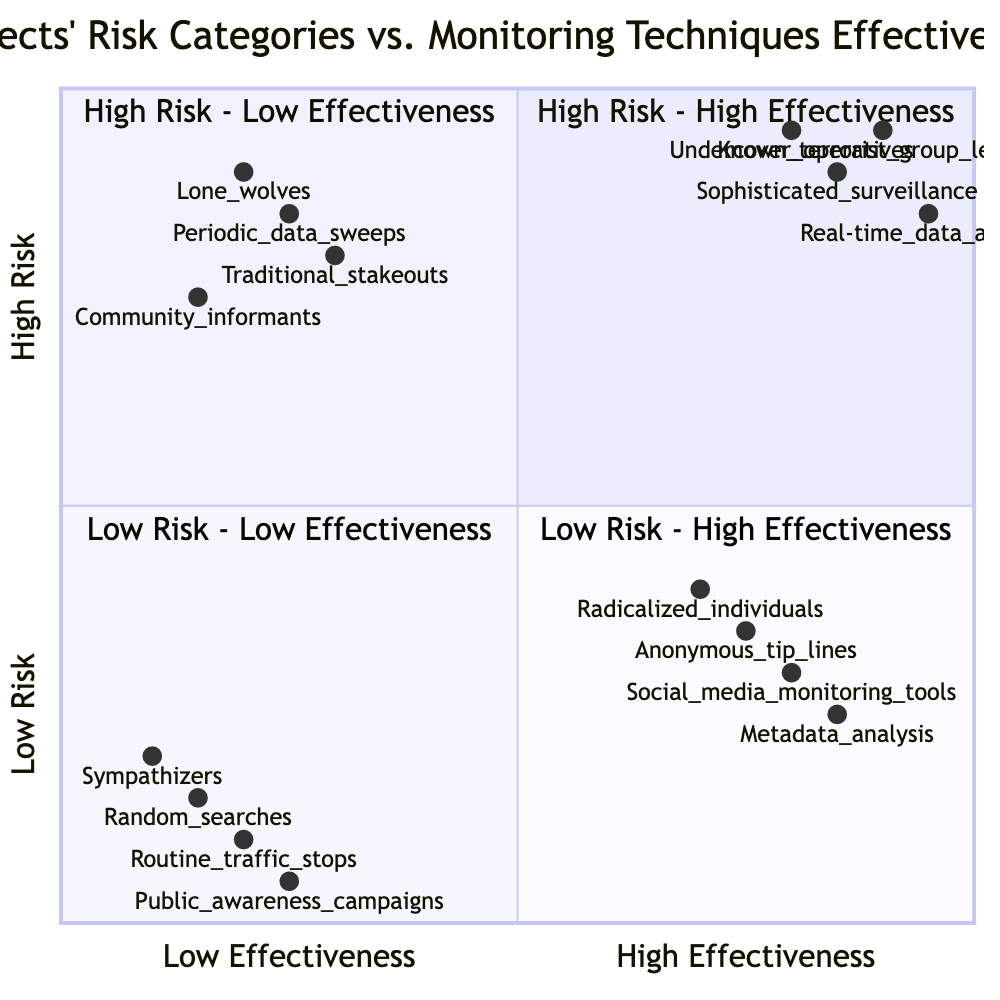What type of suspects are found in the High Risk - High Effectiveness quadrant? The High Risk - High Effectiveness quadrant includes suspects such as known terrorist group leaders. This information can be found directly labeled in the quadrant details.
Answer: Known terrorist group leaders What monitoring technique is associated with lone wolves? Lone wolves are associated with traditional stakeouts, which is specifically listed as a detail for the High Risk - Low Effectiveness quadrant.
Answer: Traditional stakeouts How many monitoring techniques are in the Low Risk - Low Effectiveness quadrant? The Low Risk - Low Effectiveness quadrant contains four monitoring techniques, each outlined in the quadrant details.
Answer: Four Which category has the highest effectiveness for monitoring techniques? The High Risk - High Effectiveness quadrant is where the most effective monitoring techniques are placed, showing superior effectiveness for high-risk suspects.
Answer: High Risk - High Effectiveness What is the effectiveness score of the metadata analysis technique? Metadata analysis is positioned at a value of 0.85 on the effectiveness scale, corresponding to its placement on the diagram.
Answer: 0.85 How do the monitoring techniques differ between High Risk - Low Effectiveness and Low Risk - High Effectiveness quadrants? The High Risk - Low Effectiveness quadrant uses techniques like traditional stakeouts, while the Low Risk - High Effectiveness quadrant employs more modern methods such as social media monitoring tools, highlighting the contrast in effectiveness despite the risk level.
Answer: Traditional stakeouts vs. social media monitoring tools What is the lowest ranked suspect category in terms of risk? The lowest ranked suspect category in terms of risk is sympathizers, which are specifically mentioned in the Low Risk - Low Effectiveness quadrant.
Answer: Sympathizers Which monitoring technique appears the most effective for low-risk suspects? The social media monitoring tools is the most effective technique for low-risk suspects, as indicated by its placement in the Low Risk - High Effectiveness quadrant.
Answer: Social media monitoring tools In terms of risk categories, which quadrant has a combination of high risk and low effectiveness? The quadrant that has a combination of high risk and low effectiveness is the High Risk - Low Effectiveness quadrant, explicitly outlined in the diagram.
Answer: High Risk - Low Effectiveness 